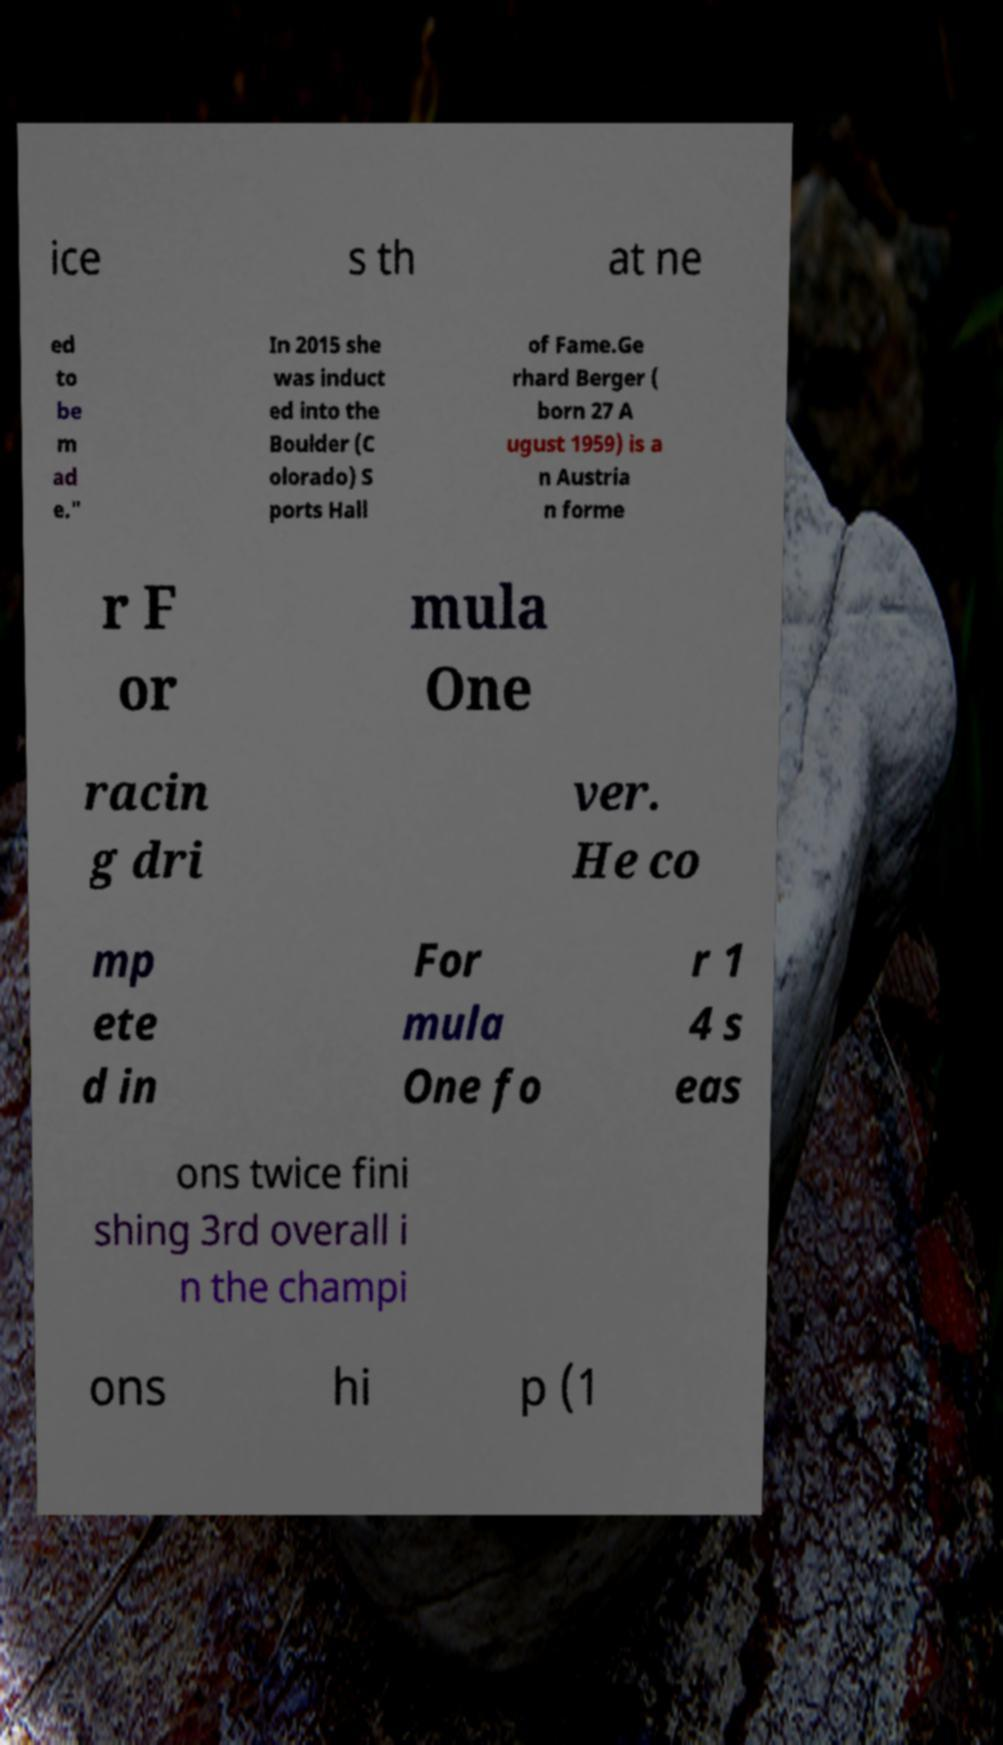Please identify and transcribe the text found in this image. ice s th at ne ed to be m ad e." In 2015 she was induct ed into the Boulder (C olorado) S ports Hall of Fame.Ge rhard Berger ( born 27 A ugust 1959) is a n Austria n forme r F or mula One racin g dri ver. He co mp ete d in For mula One fo r 1 4 s eas ons twice fini shing 3rd overall i n the champi ons hi p (1 